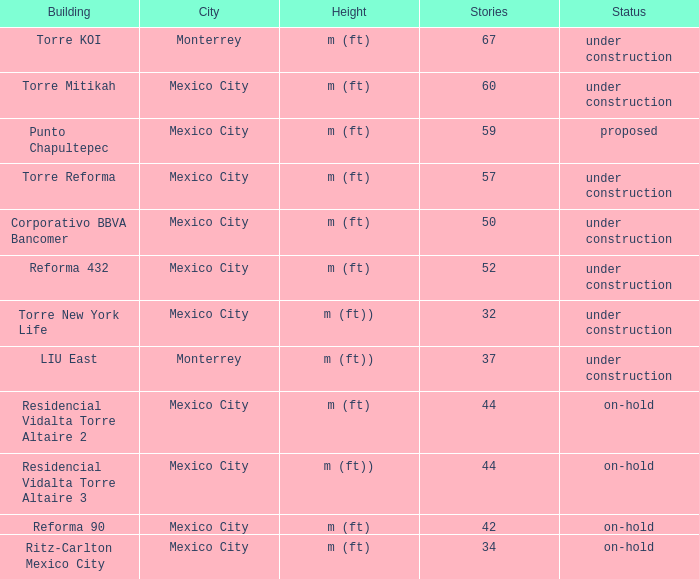How many stories is the torre reforma building? 1.0. 